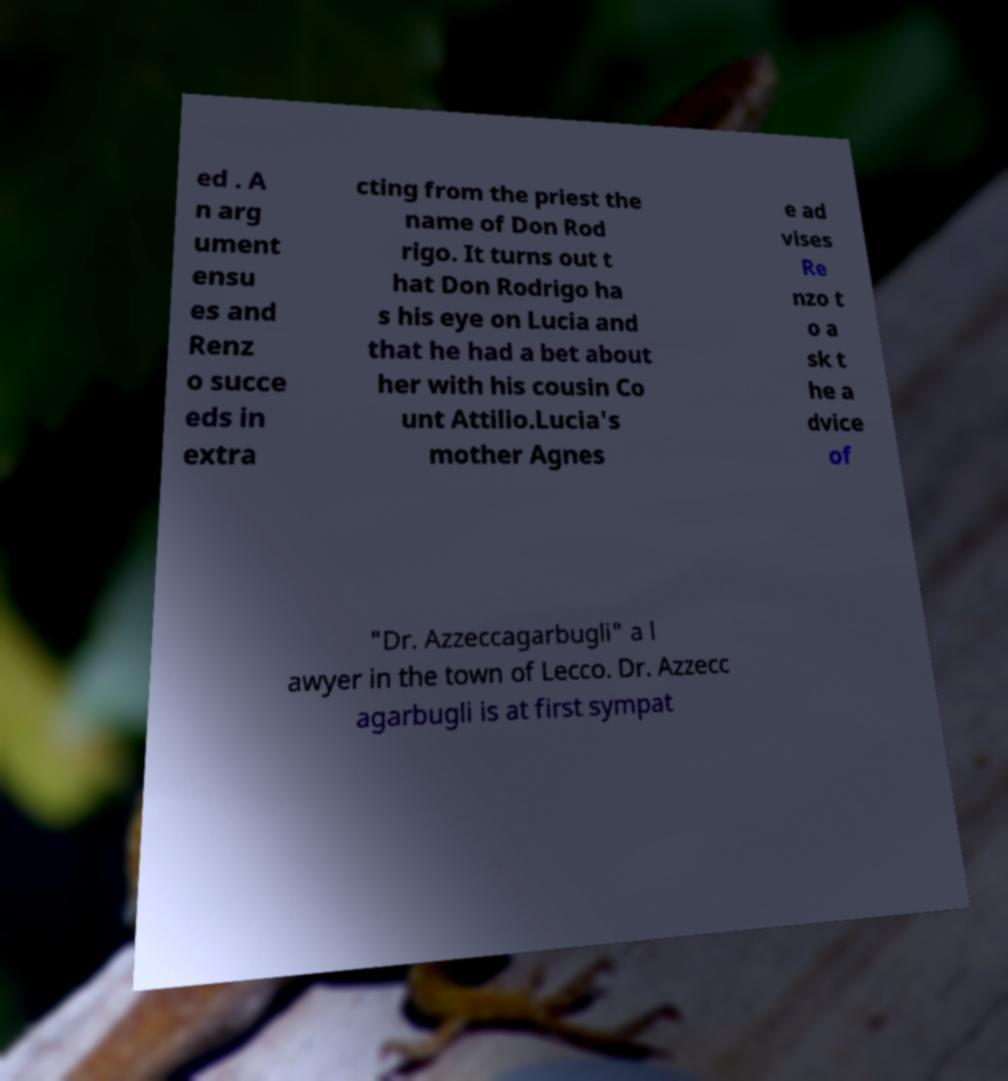I need the written content from this picture converted into text. Can you do that? ed . A n arg ument ensu es and Renz o succe eds in extra cting from the priest the name of Don Rod rigo. It turns out t hat Don Rodrigo ha s his eye on Lucia and that he had a bet about her with his cousin Co unt Attilio.Lucia's mother Agnes e ad vises Re nzo t o a sk t he a dvice of "Dr. Azzeccagarbugli" a l awyer in the town of Lecco. Dr. Azzecc agarbugli is at first sympat 